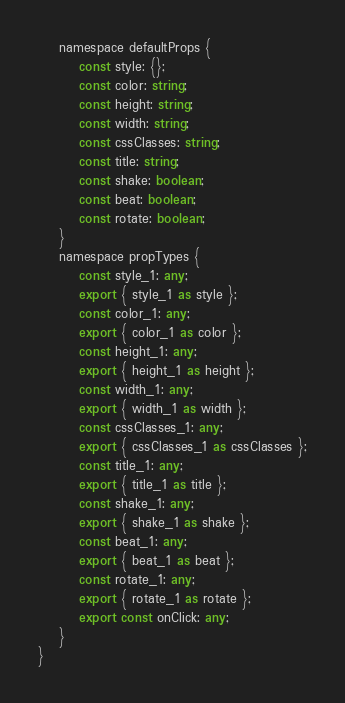Convert code to text. <code><loc_0><loc_0><loc_500><loc_500><_TypeScript_>    namespace defaultProps {
        const style: {};
        const color: string;
        const height: string;
        const width: string;
        const cssClasses: string;
        const title: string;
        const shake: boolean;
        const beat: boolean;
        const rotate: boolean;
    }
    namespace propTypes {
        const style_1: any;
        export { style_1 as style };
        const color_1: any;
        export { color_1 as color };
        const height_1: any;
        export { height_1 as height };
        const width_1: any;
        export { width_1 as width };
        const cssClasses_1: any;
        export { cssClasses_1 as cssClasses };
        const title_1: any;
        export { title_1 as title };
        const shake_1: any;
        export { shake_1 as shake };
        const beat_1: any;
        export { beat_1 as beat };
        const rotate_1: any;
        export { rotate_1 as rotate };
        export const onClick: any;
    }
}
</code> 